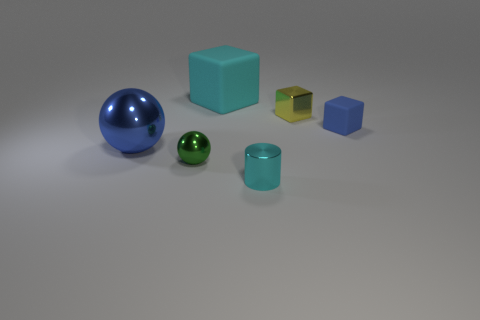Subtract all matte cubes. How many cubes are left? 1 Subtract all spheres. How many objects are left? 4 Add 3 small cyan cylinders. How many small cyan cylinders are left? 4 Add 1 small purple cylinders. How many small purple cylinders exist? 1 Add 3 big red matte cubes. How many objects exist? 9 Subtract all blue balls. How many balls are left? 1 Subtract 0 brown balls. How many objects are left? 6 Subtract 1 blocks. How many blocks are left? 2 Subtract all brown cylinders. Subtract all green cubes. How many cylinders are left? 1 Subtract all red balls. How many yellow cubes are left? 1 